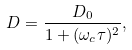<formula> <loc_0><loc_0><loc_500><loc_500>D = \frac { D _ { 0 } } { 1 + ( \omega _ { c } \tau ) ^ { 2 } } ,</formula> 